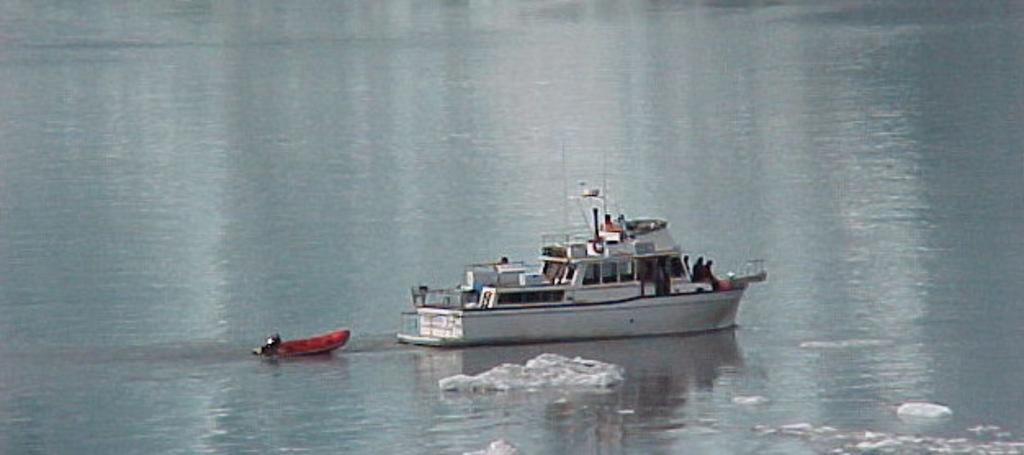What is the primary element in the image? There is water in the image. What can be seen floating on the water? There is a red boat and a white boat in the water. What type of animal is swimming in the water in the image? There are no animals visible in the image; it only features a red boat and a white boat in the water. 